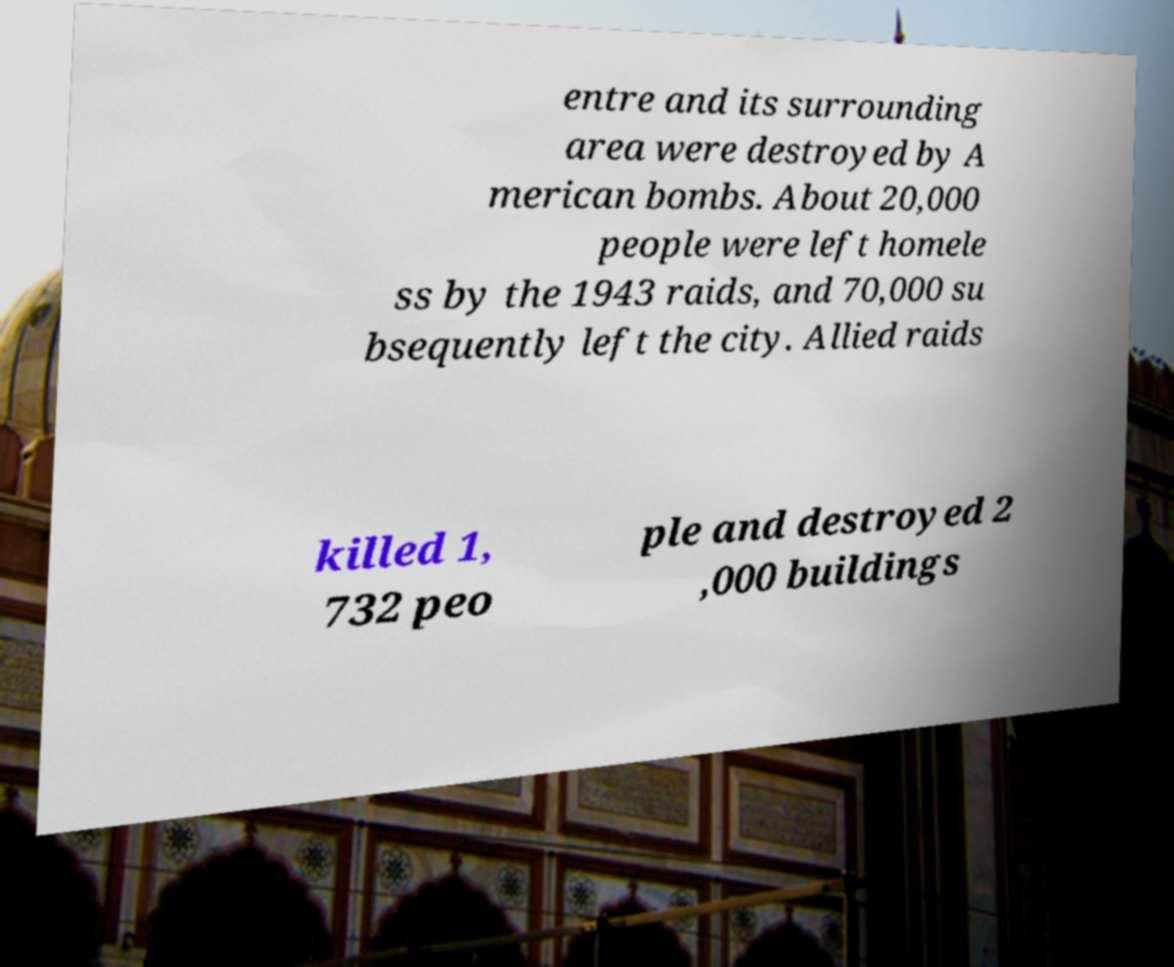Please identify and transcribe the text found in this image. entre and its surrounding area were destroyed by A merican bombs. About 20,000 people were left homele ss by the 1943 raids, and 70,000 su bsequently left the city. Allied raids killed 1, 732 peo ple and destroyed 2 ,000 buildings 